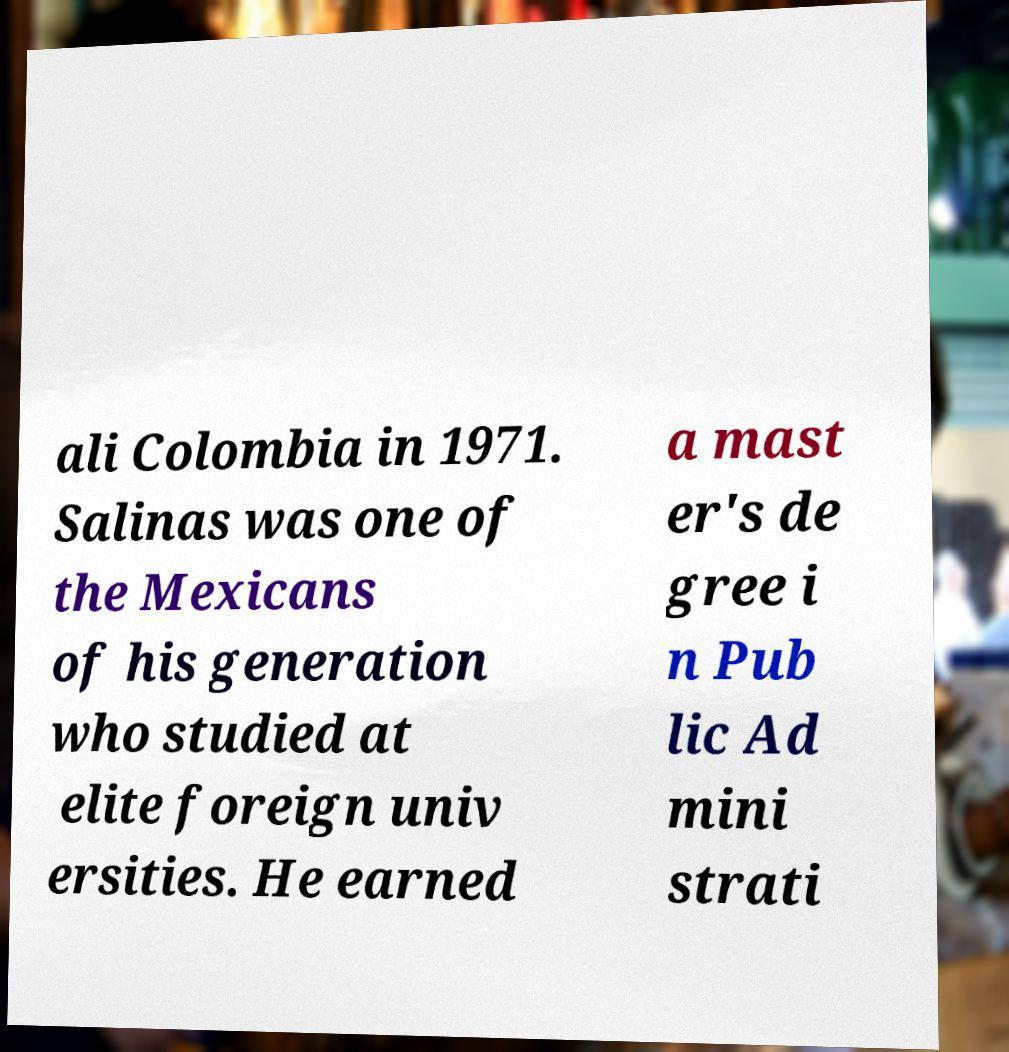Can you accurately transcribe the text from the provided image for me? ali Colombia in 1971. Salinas was one of the Mexicans of his generation who studied at elite foreign univ ersities. He earned a mast er's de gree i n Pub lic Ad mini strati 